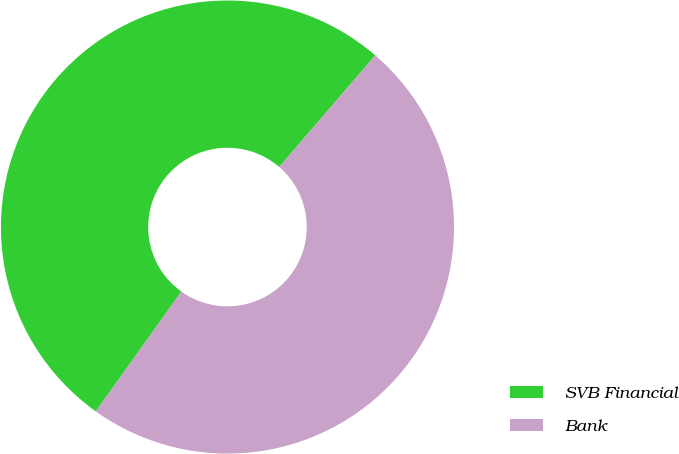<chart> <loc_0><loc_0><loc_500><loc_500><pie_chart><fcel>SVB Financial<fcel>Bank<nl><fcel>51.45%<fcel>48.55%<nl></chart> 